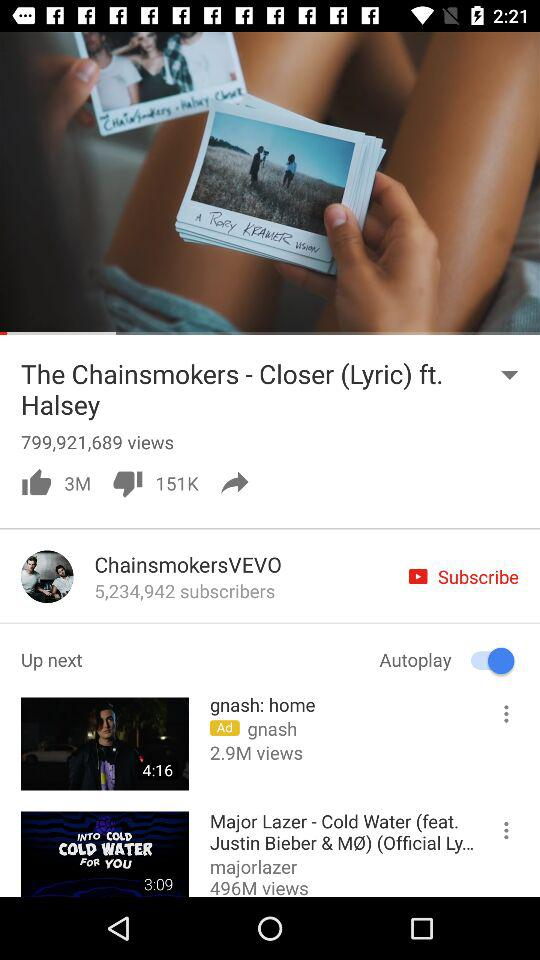What is the status of "Autoplay"? The status is "on". 